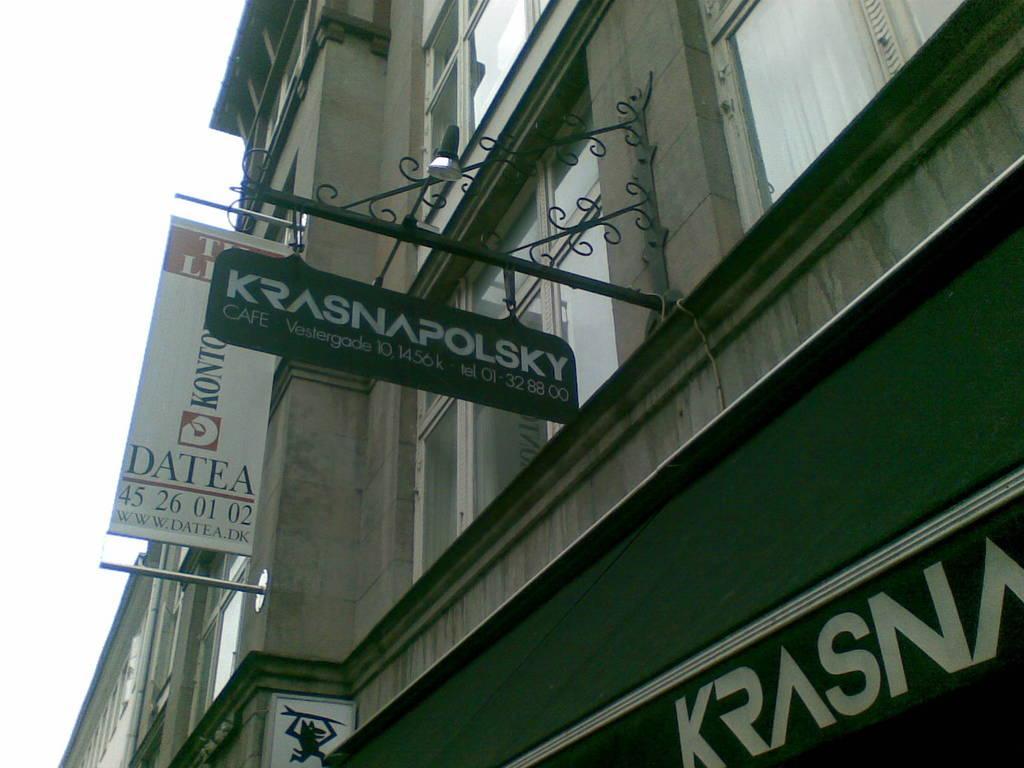Describe this image in one or two sentences. There are hoardings and a banner attached to the building, which is having glass windows. In the background, there is sky. 